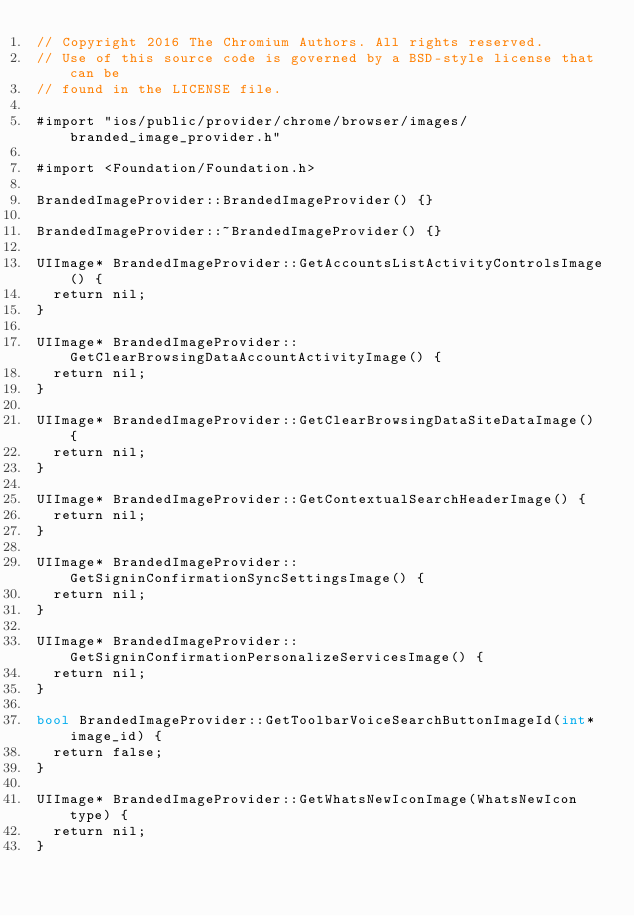<code> <loc_0><loc_0><loc_500><loc_500><_ObjectiveC_>// Copyright 2016 The Chromium Authors. All rights reserved.
// Use of this source code is governed by a BSD-style license that can be
// found in the LICENSE file.

#import "ios/public/provider/chrome/browser/images/branded_image_provider.h"

#import <Foundation/Foundation.h>

BrandedImageProvider::BrandedImageProvider() {}

BrandedImageProvider::~BrandedImageProvider() {}

UIImage* BrandedImageProvider::GetAccountsListActivityControlsImage() {
  return nil;
}

UIImage* BrandedImageProvider::GetClearBrowsingDataAccountActivityImage() {
  return nil;
}

UIImage* BrandedImageProvider::GetClearBrowsingDataSiteDataImage() {
  return nil;
}

UIImage* BrandedImageProvider::GetContextualSearchHeaderImage() {
  return nil;
}

UIImage* BrandedImageProvider::GetSigninConfirmationSyncSettingsImage() {
  return nil;
}

UIImage* BrandedImageProvider::GetSigninConfirmationPersonalizeServicesImage() {
  return nil;
}

bool BrandedImageProvider::GetToolbarVoiceSearchButtonImageId(int* image_id) {
  return false;
}

UIImage* BrandedImageProvider::GetWhatsNewIconImage(WhatsNewIcon type) {
  return nil;
}
</code> 